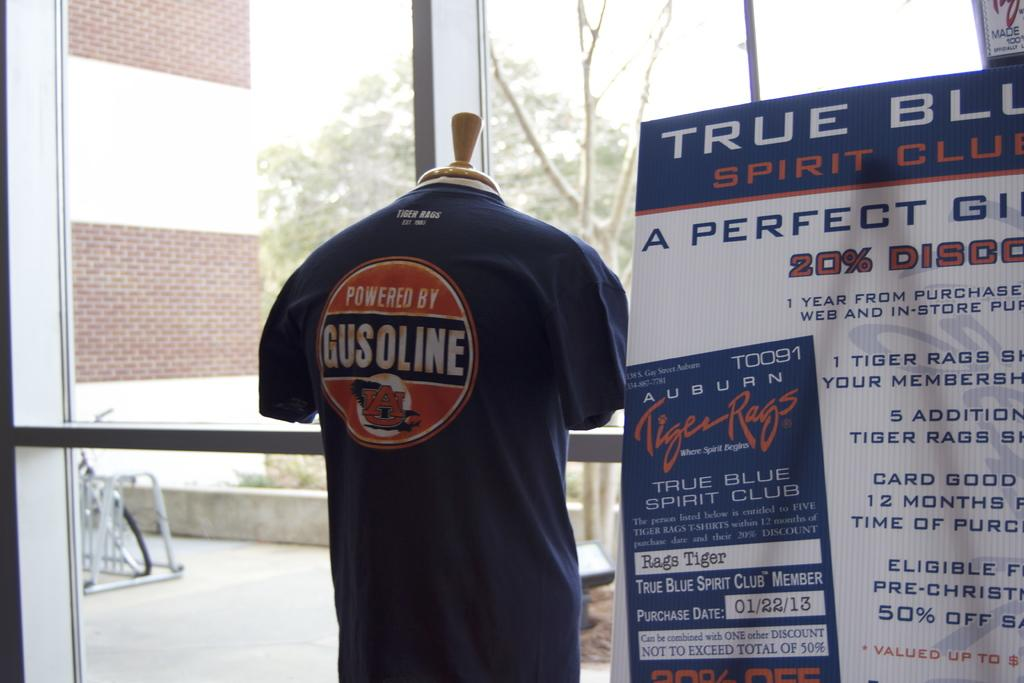<image>
Present a compact description of the photo's key features. A shirt that says, 'Powered by Gusonline' is on display on a mannequin. 